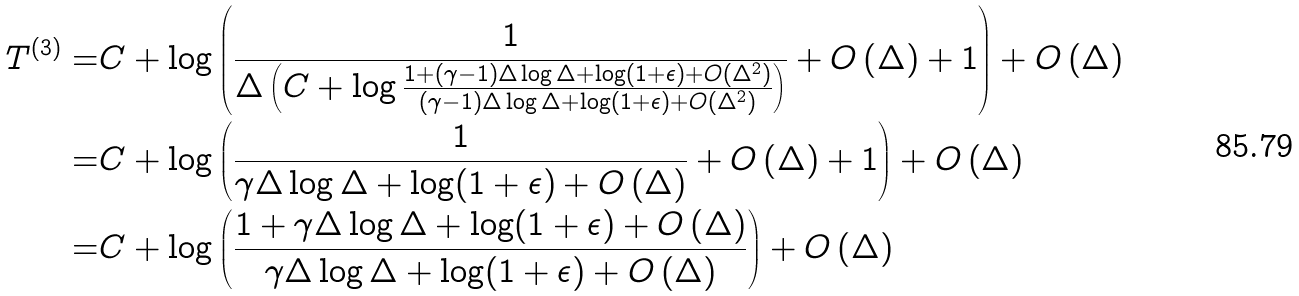<formula> <loc_0><loc_0><loc_500><loc_500>T ^ { ( 3 ) } = & C + \log \left ( \frac { 1 } { \Delta \left ( C + \log \frac { 1 + ( \gamma - 1 ) \Delta \log \Delta + \log ( 1 + \epsilon ) + O ( \Delta ^ { 2 } ) } { ( \gamma - 1 ) \Delta \log \Delta + \log ( 1 + \epsilon ) + O ( \Delta ^ { 2 } ) } \right ) } + O \left ( \Delta \right ) + 1 \right ) + O \left ( \Delta \right ) \\ = & C + \log \left ( \frac { 1 } { \gamma \Delta \log \Delta + \log ( 1 + \epsilon ) + O \left ( \Delta \right ) } + O \left ( \Delta \right ) + 1 \right ) + O \left ( \Delta \right ) \\ = & C + \log \left ( \frac { 1 + \gamma \Delta \log \Delta + \log ( 1 + \epsilon ) + O \left ( \Delta \right ) } { \gamma \Delta \log \Delta + \log ( 1 + \epsilon ) + O \left ( \Delta \right ) } \right ) + O \left ( \Delta \right )</formula> 